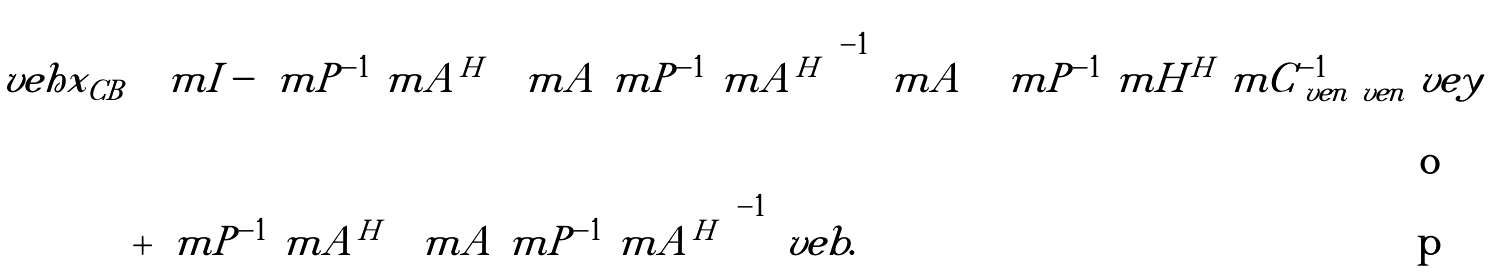Convert formula to latex. <formula><loc_0><loc_0><loc_500><loc_500>\ v e h { x } _ { C B } & \left ( \ m { I } - \ m { P } ^ { - 1 } \ m { A } ^ { H } \left ( \ m { A } \ m { P } ^ { - 1 } \ m { A } ^ { H } \right ) ^ { - 1 } \ m { A } \right ) \ m { P } ^ { - 1 } \ m { H } ^ { H } \ m { C } _ { \ v e { n } \ v e { n } } ^ { - 1 } \ v e { y } \\ & + \ m { P } ^ { - 1 } \ m { A } ^ { H } \left ( \ m { A } \ m { P } ^ { - 1 } \ m { A } ^ { H } \right ) ^ { - 1 } \ v e { b } .</formula> 